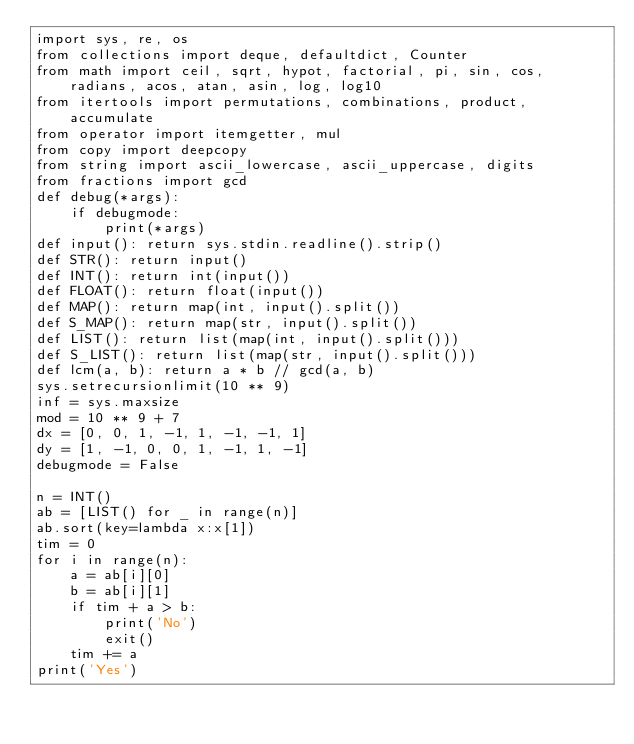Convert code to text. <code><loc_0><loc_0><loc_500><loc_500><_Python_>import sys, re, os
from collections import deque, defaultdict, Counter
from math import ceil, sqrt, hypot, factorial, pi, sin, cos, radians, acos, atan, asin, log, log10
from itertools import permutations, combinations, product, accumulate
from operator import itemgetter, mul
from copy import deepcopy
from string import ascii_lowercase, ascii_uppercase, digits
from fractions import gcd
def debug(*args):
    if debugmode:
        print(*args)
def input(): return sys.stdin.readline().strip()
def STR(): return input()
def INT(): return int(input())
def FLOAT(): return float(input())
def MAP(): return map(int, input().split())
def S_MAP(): return map(str, input().split())
def LIST(): return list(map(int, input().split()))
def S_LIST(): return list(map(str, input().split()))
def lcm(a, b): return a * b // gcd(a, b)
sys.setrecursionlimit(10 ** 9)
inf = sys.maxsize
mod = 10 ** 9 + 7
dx = [0, 0, 1, -1, 1, -1, -1, 1]
dy = [1, -1, 0, 0, 1, -1, 1, -1]
debugmode = False

n = INT()
ab = [LIST() for _ in range(n)]
ab.sort(key=lambda x:x[1])
tim = 0
for i in range(n):
    a = ab[i][0]
    b = ab[i][1]
    if tim + a > b:
        print('No')
        exit()
    tim += a
print('Yes')</code> 